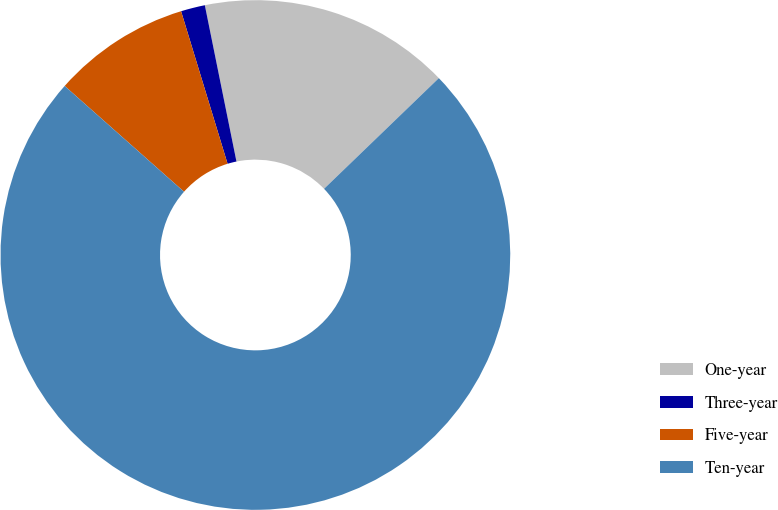Convert chart to OTSL. <chart><loc_0><loc_0><loc_500><loc_500><pie_chart><fcel>One-year<fcel>Three-year<fcel>Five-year<fcel>Ten-year<nl><fcel>15.97%<fcel>1.53%<fcel>8.75%<fcel>73.75%<nl></chart> 